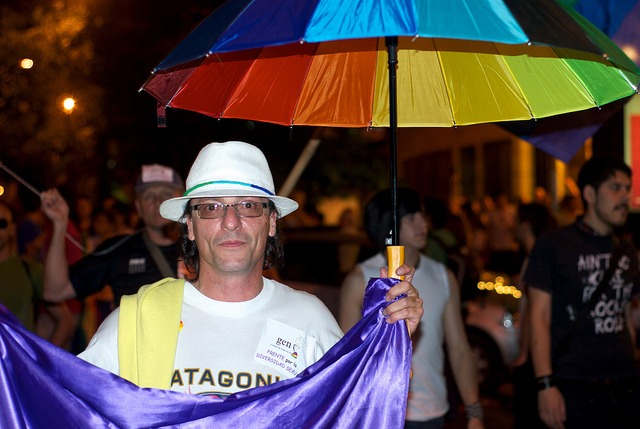What can you tell me about the event this person is attending? While I can't provide specifics about the event without more context, the person appears to be at a public gathering or street event, indicated by the people in the background and the casual attire. The colorful umbrella and the purple cloth might suggest that this is a festive or celebratory occasion, potentially a parade or a pride event. 